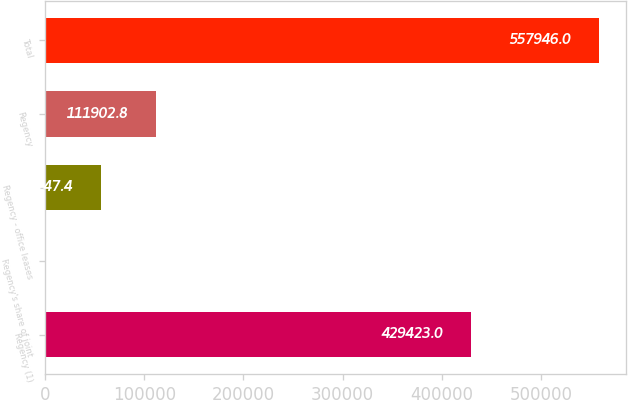Convert chart to OTSL. <chart><loc_0><loc_0><loc_500><loc_500><bar_chart><fcel>Regency (1)<fcel>Regency's share of joint<fcel>Regency - office leases<fcel>Regency<fcel>Total<nl><fcel>429423<fcel>392<fcel>56147.4<fcel>111903<fcel>557946<nl></chart> 